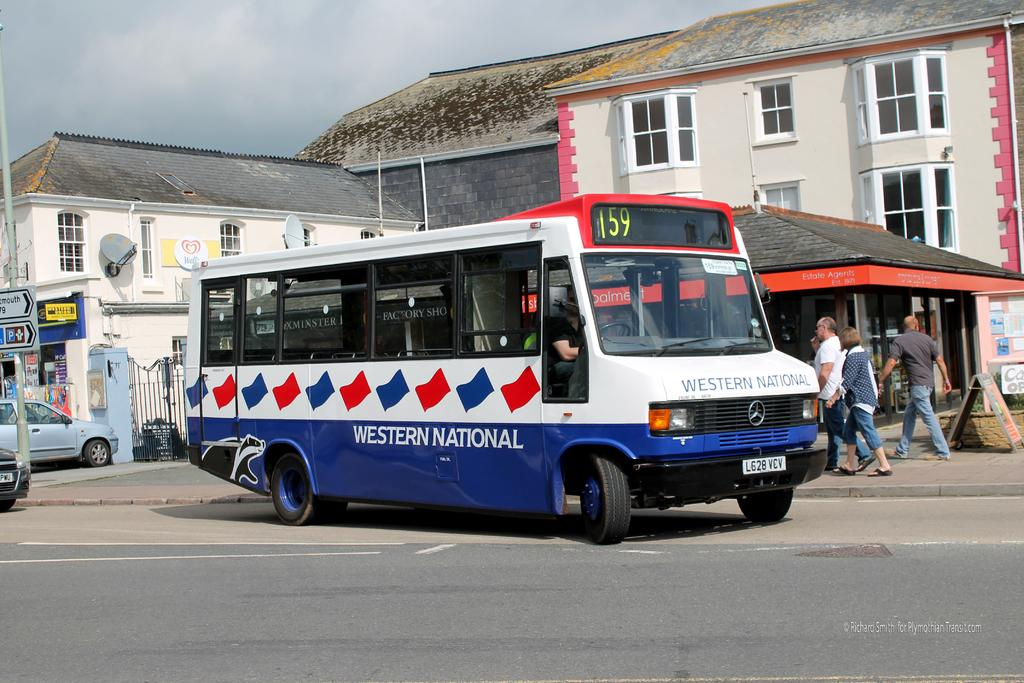<image>
Render a clear and concise summary of the photo. White and blue bus which says "Western National" on it. 